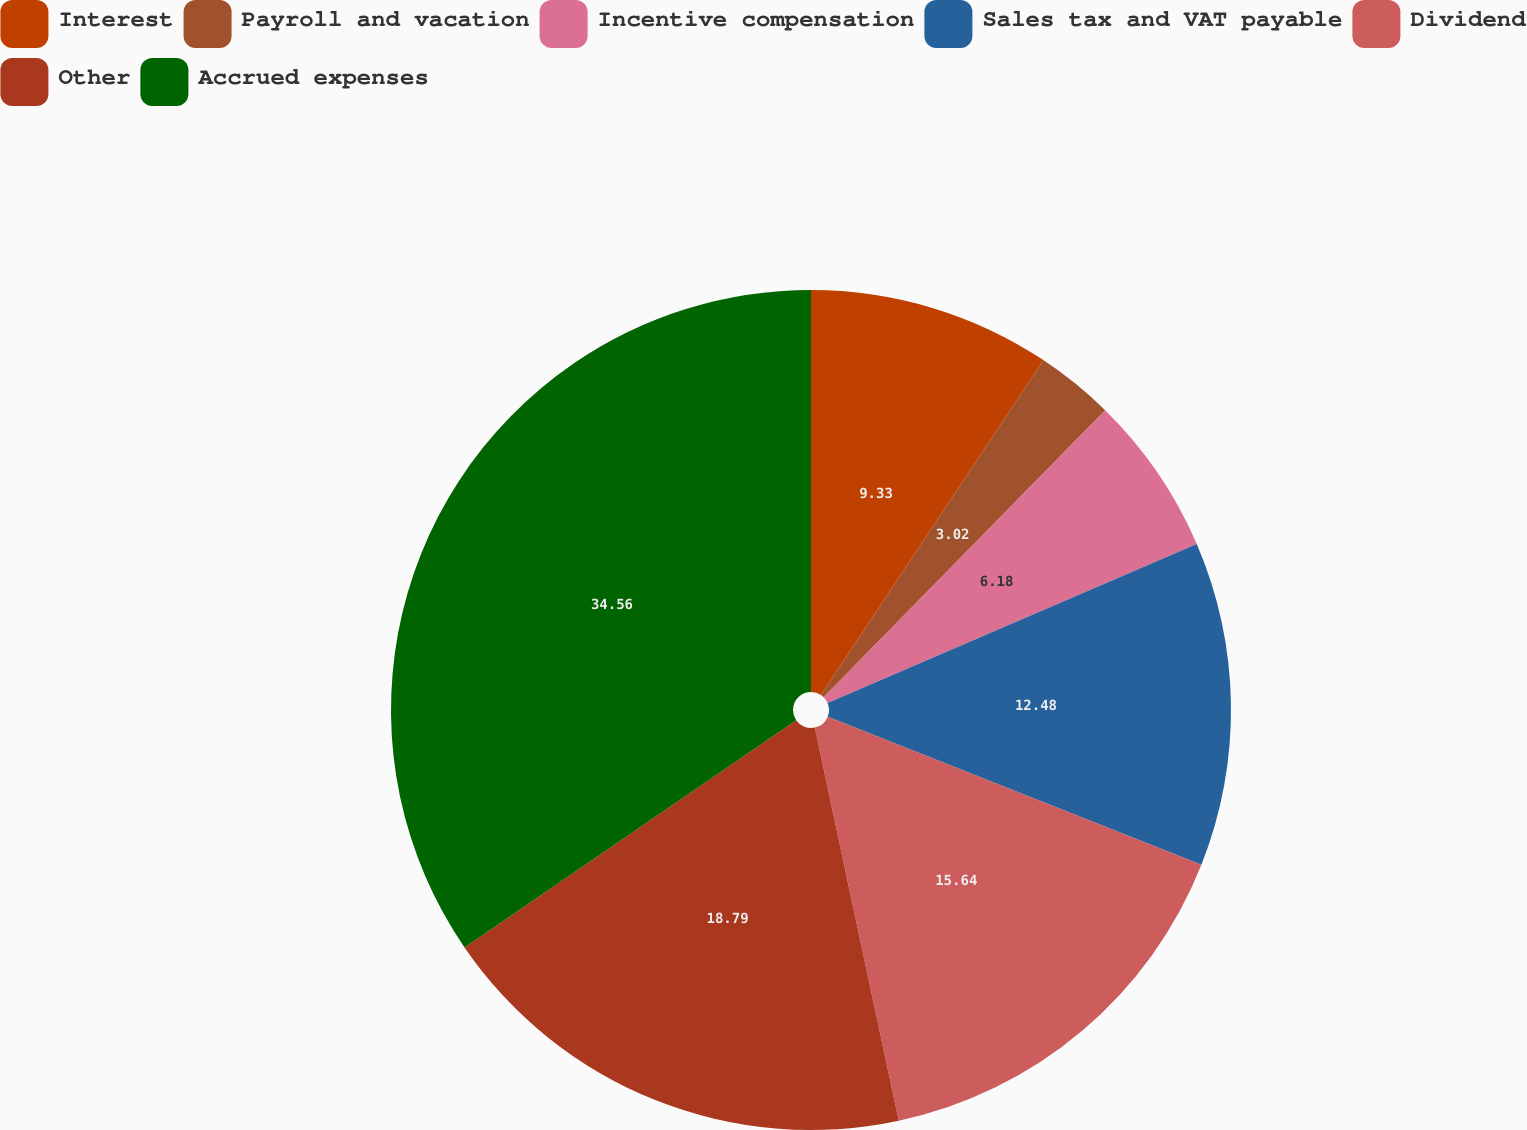Convert chart. <chart><loc_0><loc_0><loc_500><loc_500><pie_chart><fcel>Interest<fcel>Payroll and vacation<fcel>Incentive compensation<fcel>Sales tax and VAT payable<fcel>Dividend<fcel>Other<fcel>Accrued expenses<nl><fcel>9.33%<fcel>3.02%<fcel>6.18%<fcel>12.48%<fcel>15.64%<fcel>18.79%<fcel>34.56%<nl></chart> 